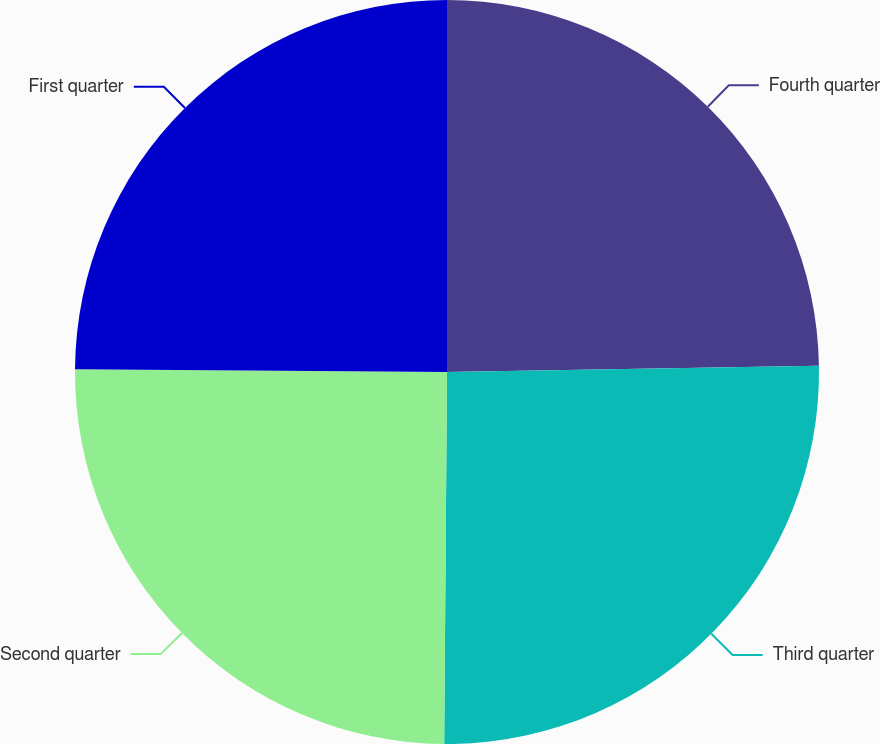Convert chart to OTSL. <chart><loc_0><loc_0><loc_500><loc_500><pie_chart><fcel>Fourth quarter<fcel>Third quarter<fcel>Second quarter<fcel>First quarter<nl><fcel>24.73%<fcel>25.39%<fcel>25.0%<fcel>24.88%<nl></chart> 